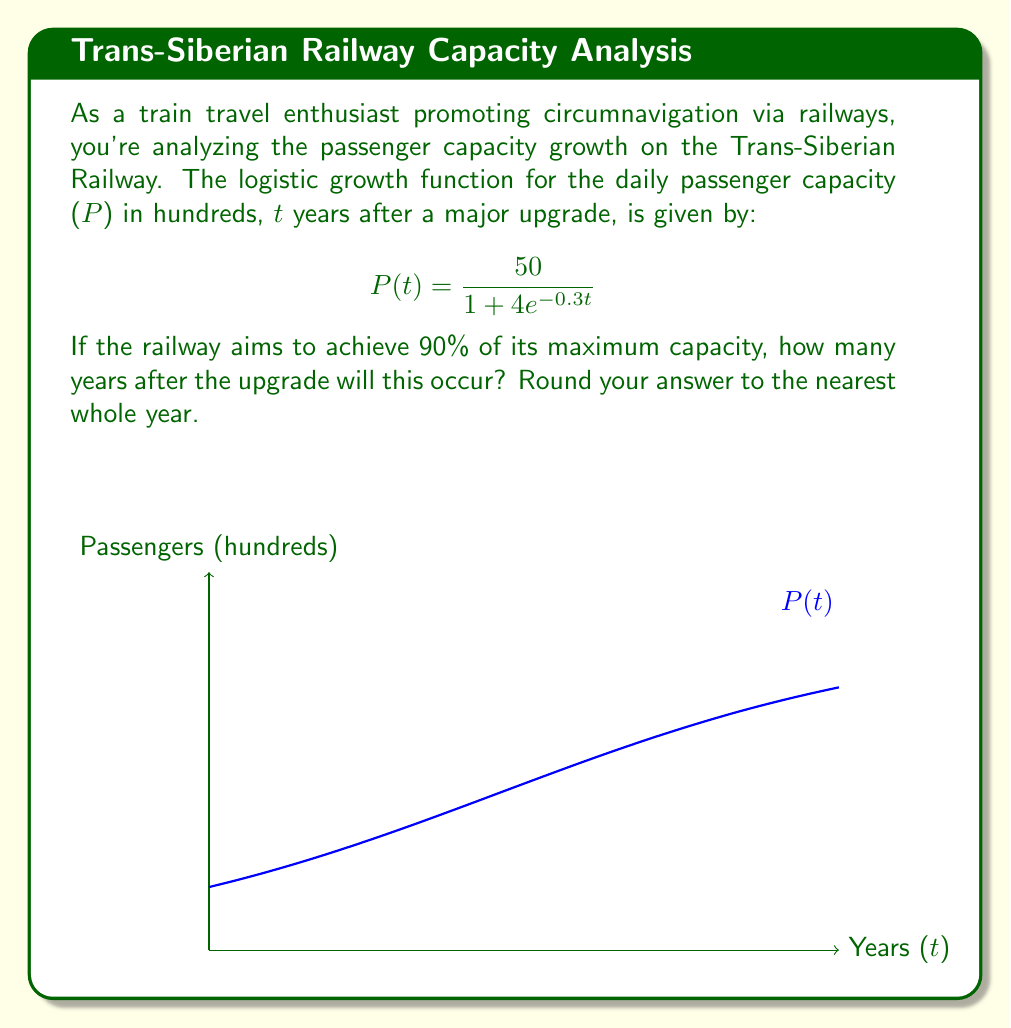Can you solve this math problem? Let's approach this step-by-step:

1) First, we need to identify the maximum capacity. In a logistic growth function, this is the value that P(t) approaches as t approaches infinity. In this case, it's 50 (hundred passengers).

2) We want to find when the capacity reaches 90% of this maximum. So we're looking for P(t) = 0.9 * 50 = 45.

3) Now we can set up our equation:

   $$45 = \frac{50}{1 + 4e^{-0.3t}}$$

4) Multiply both sides by $(1 + 4e^{-0.3t})$:

   $$45(1 + 4e^{-0.3t}) = 50$$

5) Expand:

   $$45 + 180e^{-0.3t} = 50$$

6) Subtract 45 from both sides:

   $$180e^{-0.3t} = 5$$

7) Divide both sides by 180:

   $$e^{-0.3t} = \frac{1}{36}$$

8) Take the natural log of both sides:

   $$-0.3t = \ln(\frac{1}{36})$$

9) Divide both sides by -0.3:

   $$t = -\frac{\ln(\frac{1}{36})}{0.3} \approx 11.99$$

10) Rounding to the nearest whole year:

    $$t \approx 12 \text{ years}$$
Answer: 12 years 